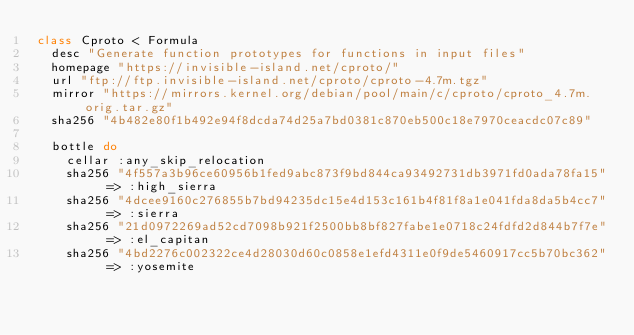<code> <loc_0><loc_0><loc_500><loc_500><_Ruby_>class Cproto < Formula
  desc "Generate function prototypes for functions in input files"
  homepage "https://invisible-island.net/cproto/"
  url "ftp://ftp.invisible-island.net/cproto/cproto-4.7m.tgz"
  mirror "https://mirrors.kernel.org/debian/pool/main/c/cproto/cproto_4.7m.orig.tar.gz"
  sha256 "4b482e80f1b492e94f8dcda74d25a7bd0381c870eb500c18e7970ceacdc07c89"

  bottle do
    cellar :any_skip_relocation
    sha256 "4f557a3b96ce60956b1fed9abc873f9bd844ca93492731db3971fd0ada78fa15" => :high_sierra
    sha256 "4dcee9160c276855b7bd94235dc15e4d153c161b4f81f8a1e041fda8da5b4cc7" => :sierra
    sha256 "21d0972269ad52cd7098b921f2500bb8bf827fabe1e0718c24fdfd2d844b7f7e" => :el_capitan
    sha256 "4bd2276c002322ce4d28030d60c0858e1efd4311e0f9de5460917cc5b70bc362" => :yosemite</code> 